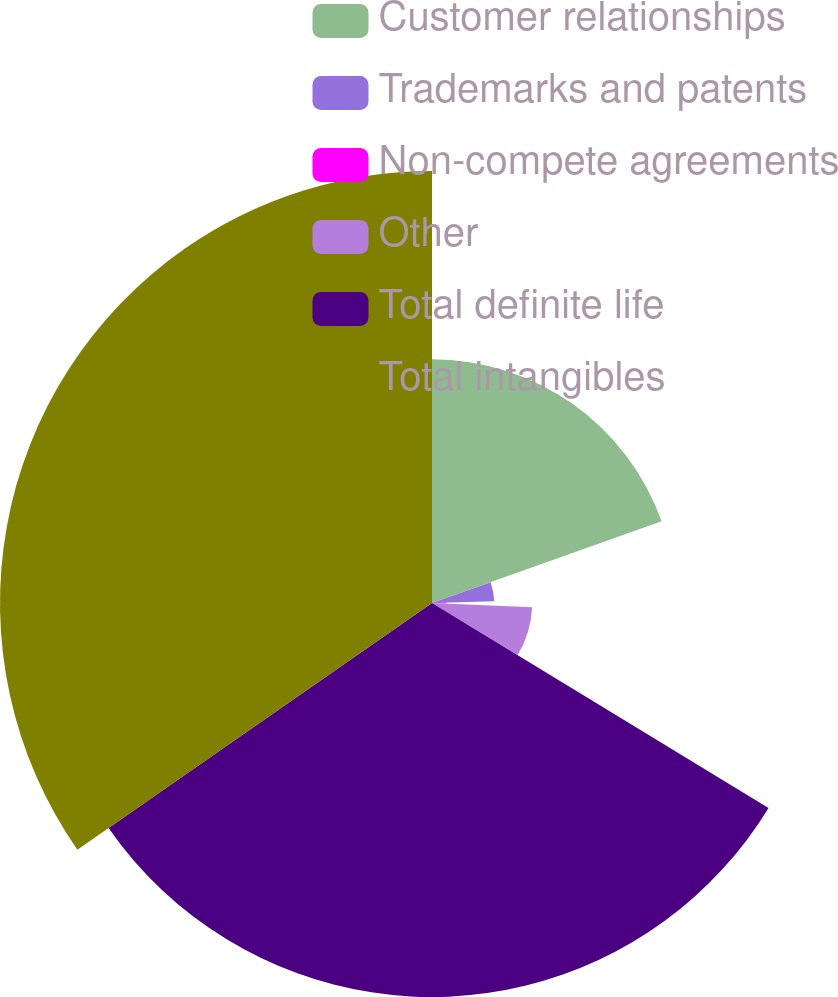Convert chart. <chart><loc_0><loc_0><loc_500><loc_500><pie_chart><fcel>Customer relationships<fcel>Trademarks and patents<fcel>Non-compete agreements<fcel>Other<fcel>Total definite life<fcel>Total intangibles<nl><fcel>19.56%<fcel>4.99%<fcel>1.11%<fcel>8.04%<fcel>31.62%<fcel>34.67%<nl></chart> 